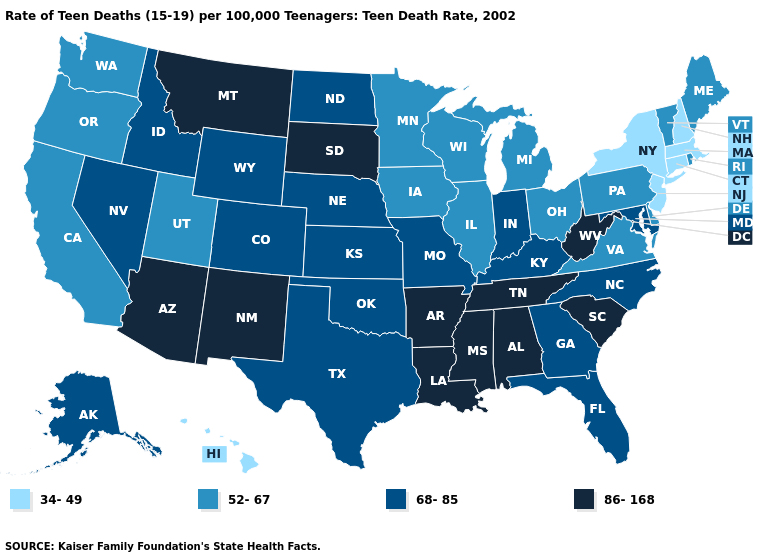What is the lowest value in states that border Massachusetts?
Write a very short answer. 34-49. What is the lowest value in the USA?
Short answer required. 34-49. Among the states that border New Mexico , does Arizona have the highest value?
Give a very brief answer. Yes. Does Minnesota have a lower value than Oklahoma?
Answer briefly. Yes. Does North Carolina have the highest value in the South?
Answer briefly. No. What is the value of Delaware?
Concise answer only. 52-67. What is the value of Wisconsin?
Give a very brief answer. 52-67. What is the value of Washington?
Be succinct. 52-67. Does Connecticut have the highest value in the Northeast?
Keep it brief. No. What is the value of North Dakota?
Answer briefly. 68-85. What is the value of New York?
Give a very brief answer. 34-49. Does Indiana have the lowest value in the MidWest?
Answer briefly. No. What is the value of Montana?
Answer briefly. 86-168. What is the value of Nebraska?
Keep it brief. 68-85. Name the states that have a value in the range 86-168?
Give a very brief answer. Alabama, Arizona, Arkansas, Louisiana, Mississippi, Montana, New Mexico, South Carolina, South Dakota, Tennessee, West Virginia. 